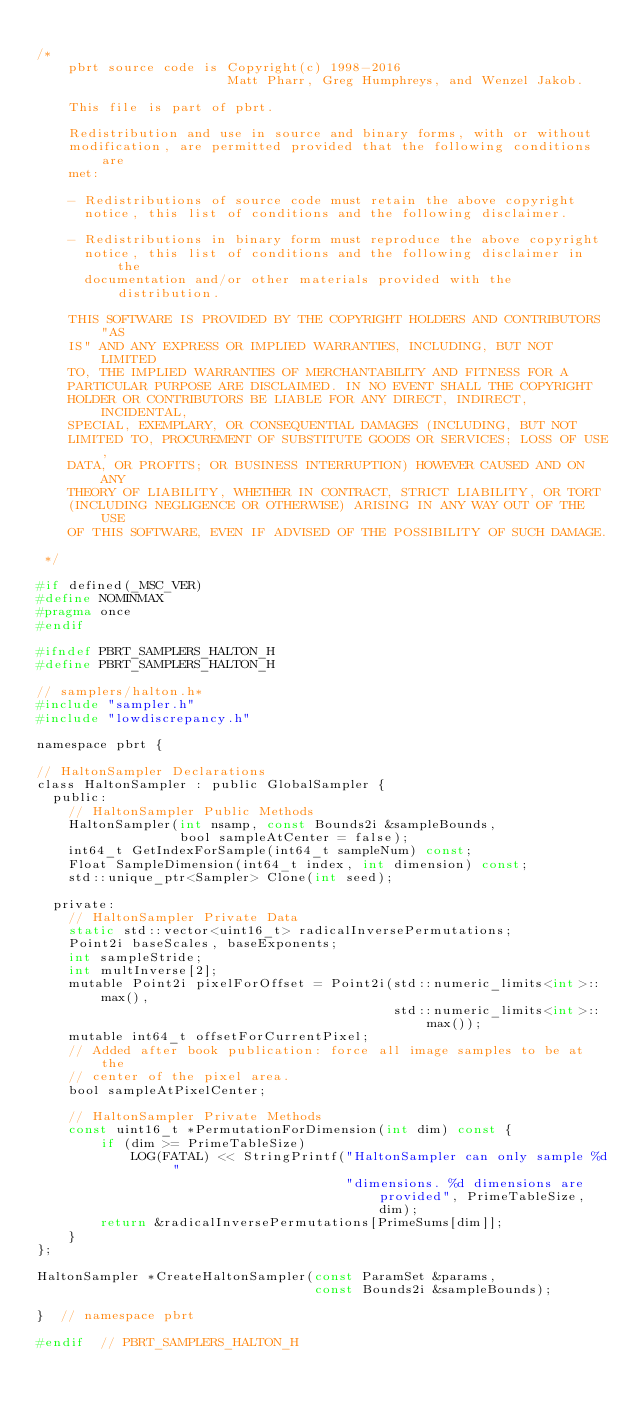<code> <loc_0><loc_0><loc_500><loc_500><_C_>
/*
    pbrt source code is Copyright(c) 1998-2016
                        Matt Pharr, Greg Humphreys, and Wenzel Jakob.

    This file is part of pbrt.

    Redistribution and use in source and binary forms, with or without
    modification, are permitted provided that the following conditions are
    met:

    - Redistributions of source code must retain the above copyright
      notice, this list of conditions and the following disclaimer.

    - Redistributions in binary form must reproduce the above copyright
      notice, this list of conditions and the following disclaimer in the
      documentation and/or other materials provided with the distribution.

    THIS SOFTWARE IS PROVIDED BY THE COPYRIGHT HOLDERS AND CONTRIBUTORS "AS
    IS" AND ANY EXPRESS OR IMPLIED WARRANTIES, INCLUDING, BUT NOT LIMITED
    TO, THE IMPLIED WARRANTIES OF MERCHANTABILITY AND FITNESS FOR A
    PARTICULAR PURPOSE ARE DISCLAIMED. IN NO EVENT SHALL THE COPYRIGHT
    HOLDER OR CONTRIBUTORS BE LIABLE FOR ANY DIRECT, INDIRECT, INCIDENTAL,
    SPECIAL, EXEMPLARY, OR CONSEQUENTIAL DAMAGES (INCLUDING, BUT NOT
    LIMITED TO, PROCUREMENT OF SUBSTITUTE GOODS OR SERVICES; LOSS OF USE,
    DATA, OR PROFITS; OR BUSINESS INTERRUPTION) HOWEVER CAUSED AND ON ANY
    THEORY OF LIABILITY, WHETHER IN CONTRACT, STRICT LIABILITY, OR TORT
    (INCLUDING NEGLIGENCE OR OTHERWISE) ARISING IN ANY WAY OUT OF THE USE
    OF THIS SOFTWARE, EVEN IF ADVISED OF THE POSSIBILITY OF SUCH DAMAGE.

 */

#if defined(_MSC_VER)
#define NOMINMAX
#pragma once
#endif

#ifndef PBRT_SAMPLERS_HALTON_H
#define PBRT_SAMPLERS_HALTON_H

// samplers/halton.h*
#include "sampler.h"
#include "lowdiscrepancy.h"

namespace pbrt {

// HaltonSampler Declarations
class HaltonSampler : public GlobalSampler {
  public:
    // HaltonSampler Public Methods
    HaltonSampler(int nsamp, const Bounds2i &sampleBounds,
                  bool sampleAtCenter = false);
    int64_t GetIndexForSample(int64_t sampleNum) const;
    Float SampleDimension(int64_t index, int dimension) const;
    std::unique_ptr<Sampler> Clone(int seed);

  private:
    // HaltonSampler Private Data
    static std::vector<uint16_t> radicalInversePermutations;
    Point2i baseScales, baseExponents;
    int sampleStride;
    int multInverse[2];
    mutable Point2i pixelForOffset = Point2i(std::numeric_limits<int>::max(),
                                             std::numeric_limits<int>::max());
    mutable int64_t offsetForCurrentPixel;
    // Added after book publication: force all image samples to be at the
    // center of the pixel area.
    bool sampleAtPixelCenter;

    // HaltonSampler Private Methods
    const uint16_t *PermutationForDimension(int dim) const {
        if (dim >= PrimeTableSize)
            LOG(FATAL) << StringPrintf("HaltonSampler can only sample %d "
                                       "dimensions. %d dimensions are provided", PrimeTableSize, dim);
        return &radicalInversePermutations[PrimeSums[dim]];
    }
};

HaltonSampler *CreateHaltonSampler(const ParamSet &params,
                                   const Bounds2i &sampleBounds);

}  // namespace pbrt

#endif  // PBRT_SAMPLERS_HALTON_H
</code> 